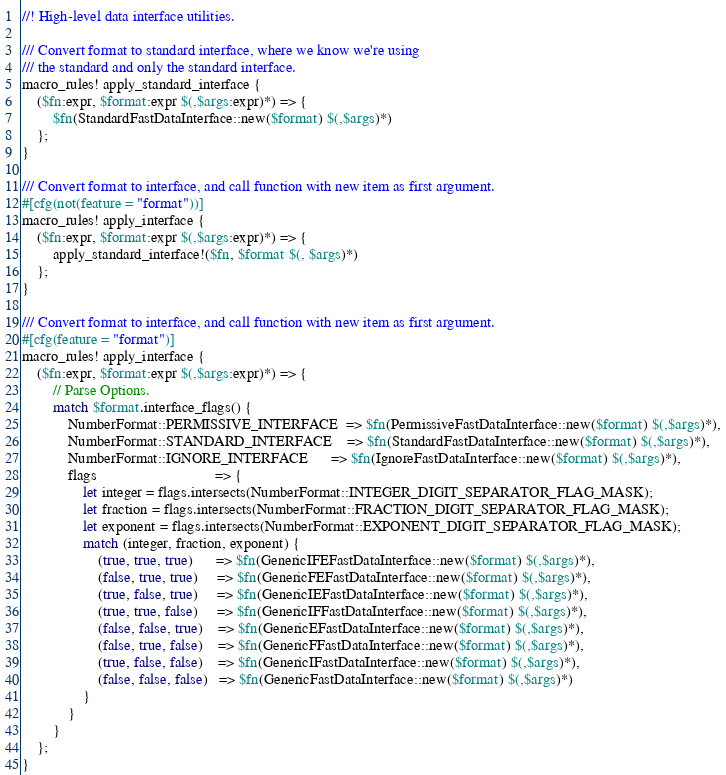Convert code to text. <code><loc_0><loc_0><loc_500><loc_500><_Rust_>//! High-level data interface utilities.

/// Convert format to standard interface, where we know we're using
/// the standard and only the standard interface.
macro_rules! apply_standard_interface {
    ($fn:expr, $format:expr $(,$args:expr)*) => {
        $fn(StandardFastDataInterface::new($format) $(,$args)*)
    };
}

/// Convert format to interface, and call function with new item as first argument.
#[cfg(not(feature = "format"))]
macro_rules! apply_interface {
    ($fn:expr, $format:expr $(,$args:expr)*) => {
        apply_standard_interface!($fn, $format $(, $args)*)
    };
}

/// Convert format to interface, and call function with new item as first argument.
#[cfg(feature = "format")]
macro_rules! apply_interface {
    ($fn:expr, $format:expr $(,$args:expr)*) => {
        // Parse Options.
        match $format.interface_flags() {
            NumberFormat::PERMISSIVE_INTERFACE  => $fn(PermissiveFastDataInterface::new($format) $(,$args)*),
            NumberFormat::STANDARD_INTERFACE    => $fn(StandardFastDataInterface::new($format) $(,$args)*),
            NumberFormat::IGNORE_INTERFACE      => $fn(IgnoreFastDataInterface::new($format) $(,$args)*),
            flags                               => {
                let integer = flags.intersects(NumberFormat::INTEGER_DIGIT_SEPARATOR_FLAG_MASK);
                let fraction = flags.intersects(NumberFormat::FRACTION_DIGIT_SEPARATOR_FLAG_MASK);
                let exponent = flags.intersects(NumberFormat::EXPONENT_DIGIT_SEPARATOR_FLAG_MASK);
                match (integer, fraction, exponent) {
                    (true, true, true)      => $fn(GenericIFEFastDataInterface::new($format) $(,$args)*),
                    (false, true, true)     => $fn(GenericFEFastDataInterface::new($format) $(,$args)*),
                    (true, false, true)     => $fn(GenericIEFastDataInterface::new($format) $(,$args)*),
                    (true, true, false)     => $fn(GenericIFFastDataInterface::new($format) $(,$args)*),
                    (false, false, true)    => $fn(GenericEFastDataInterface::new($format) $(,$args)*),
                    (false, true, false)    => $fn(GenericFFastDataInterface::new($format) $(,$args)*),
                    (true, false, false)    => $fn(GenericIFastDataInterface::new($format) $(,$args)*),
                    (false, false, false)   => $fn(GenericFastDataInterface::new($format) $(,$args)*)
                }
            }
        }
    };
}
</code> 